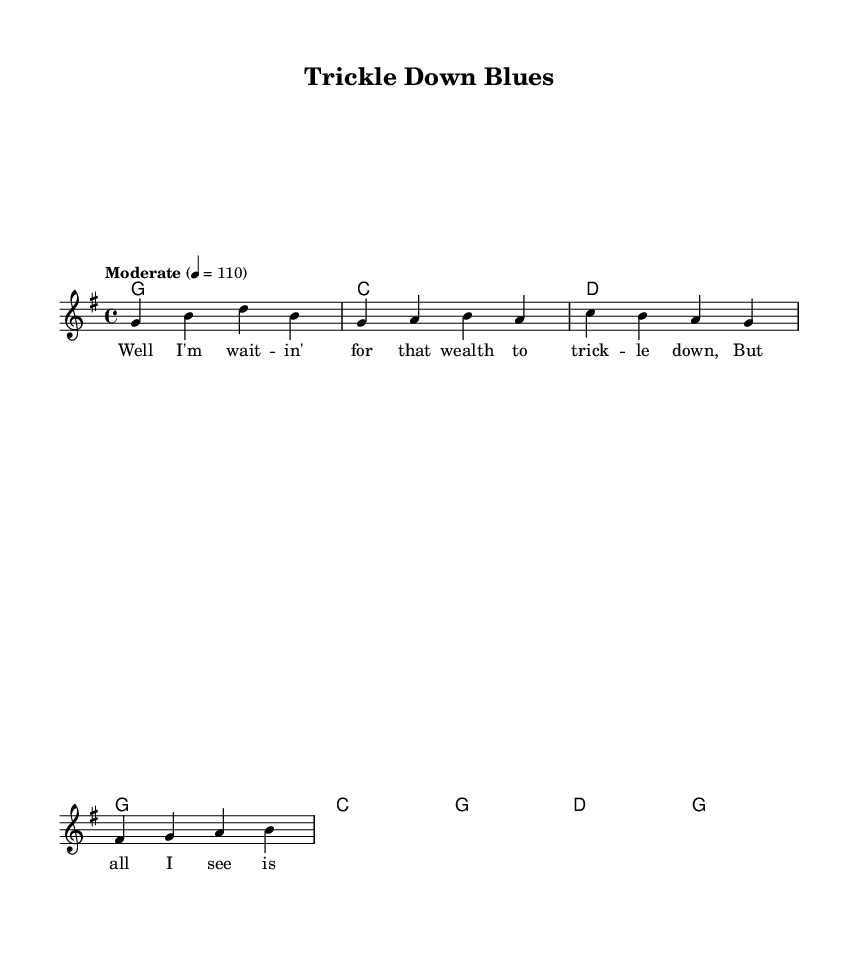What is the key signature of this music? The key signature indicates G major, which has one sharp (F#). This can be confirmed by looking at the global music settings at the beginning.
Answer: G major What is the time signature of this music? The time signature is indicated as 4/4, meaning there are four beats in each measure and the quarter note gets one beat. This is found in the global settings as well.
Answer: 4/4 What is the tempo marking of this music? The tempo marking states "Moderate" with a tempo of 110 beats per minute, which can be seen in the global music settings section.
Answer: Moderate, 110 How many measures are in the verse section? The verse section consists of four measures, which can be identified by counting the measures in the melody line related to the verse chords.
Answer: 4 What are the chords used in the chorus? The chorus uses the chords C, G, D, and G, listed in the chord mode section for the chorus. These chords define the harmonic structure of the chorus.
Answer: C, G, D, G What type of lyrics are used in this song? The lyrics feature satirical elements about economic theories, particularly focusing on the notion of "trickle down" economics, which is evident in the thematic content expressed in the verse and chorus.
Answer: Satirical What is the lyrical theme of the song? The song revolves around the theme of waiting for economic benefits to "trickle down," reflecting skepticism regarding economic policies. This message is conveyed through both verses and repetition in the chorus.
Answer: Economic skepticism 